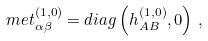Convert formula to latex. <formula><loc_0><loc_0><loc_500><loc_500>\ m e t _ { \alpha \beta } ^ { ( 1 , 0 ) } = d i a g \left ( h _ { A B } ^ { ( 1 , 0 ) } , 0 \right ) \, ,</formula> 